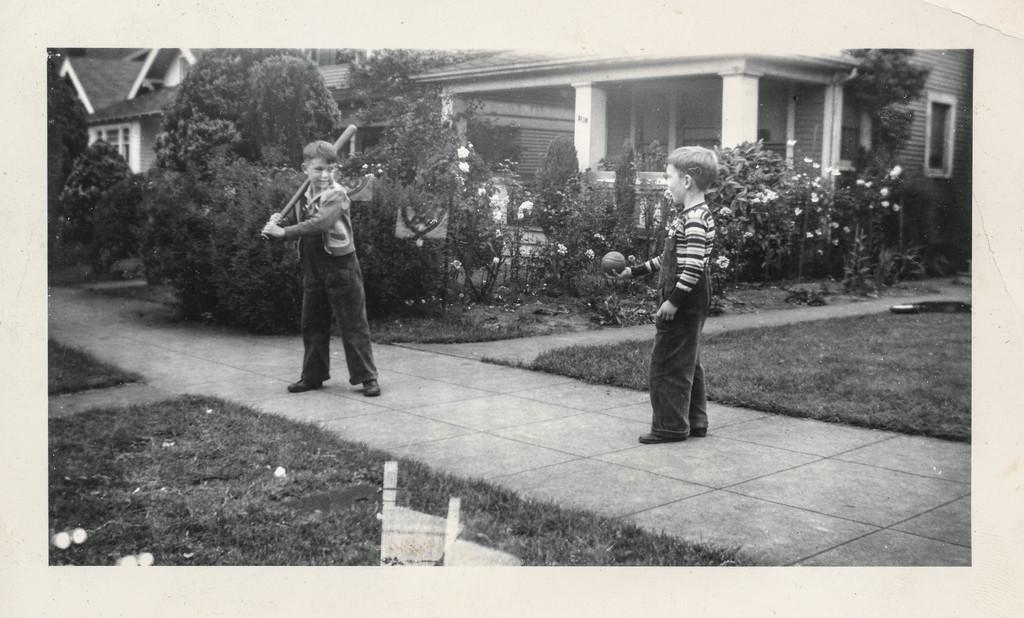How many boys are in the image? There are two boys in the image. What are the boys doing in the image? The boys are standing on a pavement. What is one of the boys holding? One of the boys is holding a bat. What type of vegetation can be seen in the image? There are garden plants in the image. What type of structures are visible in the image? There are buildings visible in the image. Where is the mailbox located in the image? There is no mailbox present in the image. What is the boys' mom doing in the image? There is no mom present in the image. 